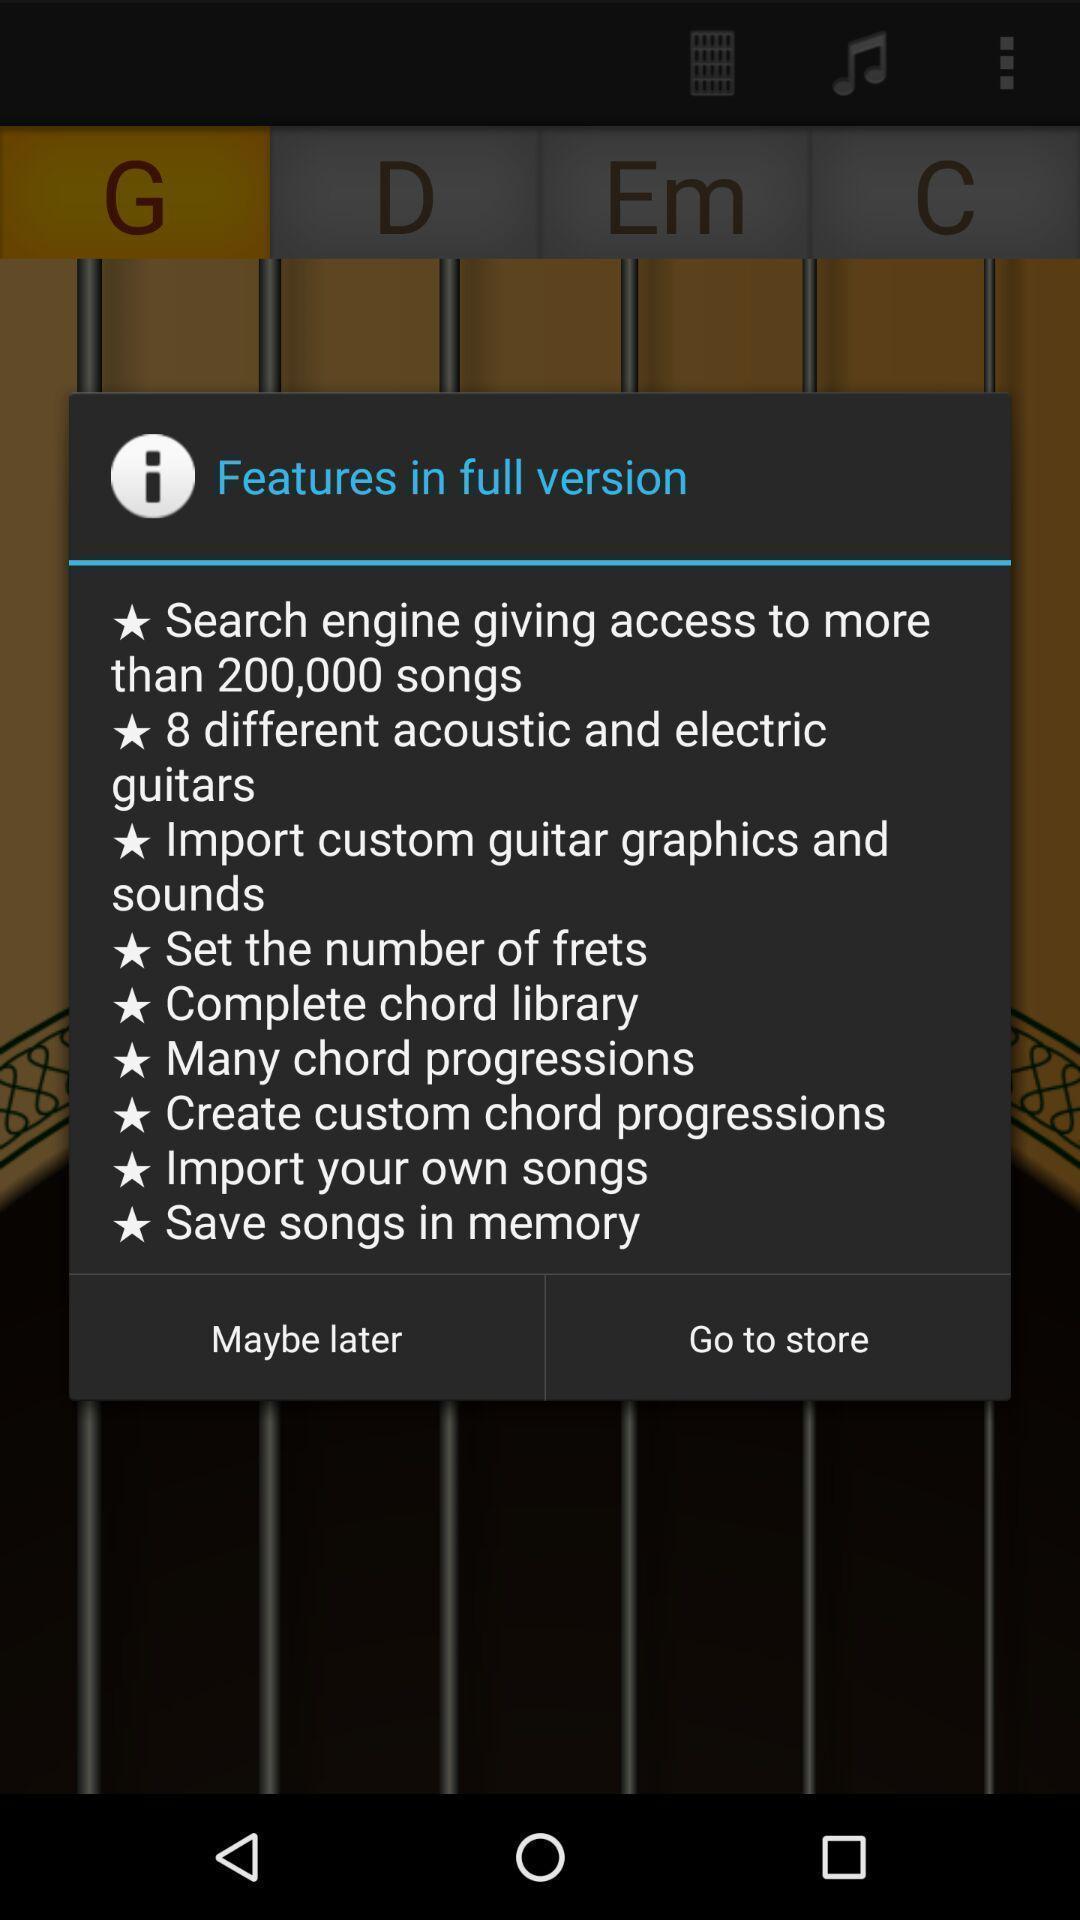Give me a narrative description of this picture. Pop-up showing features in full version. 